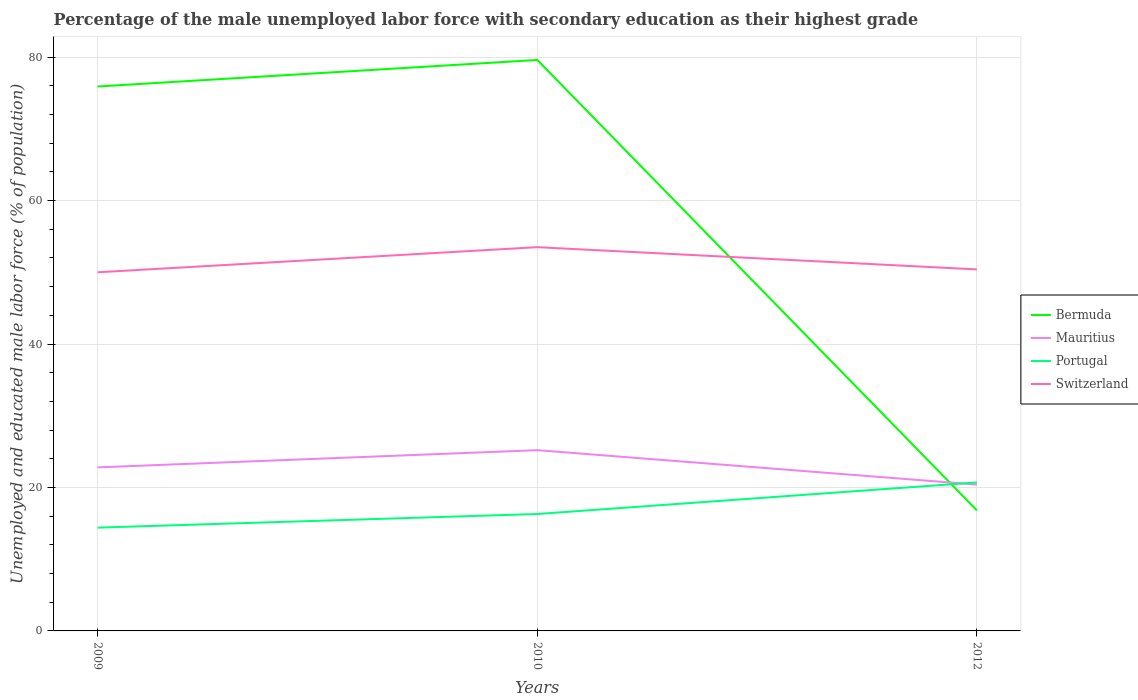How many different coloured lines are there?
Keep it short and to the point. 4. Does the line corresponding to Portugal intersect with the line corresponding to Switzerland?
Offer a very short reply. No. Across all years, what is the maximum percentage of the unemployed male labor force with secondary education in Portugal?
Give a very brief answer. 14.4. What is the total percentage of the unemployed male labor force with secondary education in Bermuda in the graph?
Give a very brief answer. 59.1. What is the difference between the highest and the second highest percentage of the unemployed male labor force with secondary education in Mauritius?
Give a very brief answer. 4.8. Is the percentage of the unemployed male labor force with secondary education in Mauritius strictly greater than the percentage of the unemployed male labor force with secondary education in Switzerland over the years?
Offer a terse response. Yes. How many lines are there?
Provide a succinct answer. 4. What is the difference between two consecutive major ticks on the Y-axis?
Make the answer very short. 20. Are the values on the major ticks of Y-axis written in scientific E-notation?
Provide a short and direct response. No. Does the graph contain any zero values?
Your answer should be compact. No. Does the graph contain grids?
Provide a succinct answer. Yes. How are the legend labels stacked?
Your response must be concise. Vertical. What is the title of the graph?
Offer a very short reply. Percentage of the male unemployed labor force with secondary education as their highest grade. What is the label or title of the X-axis?
Offer a terse response. Years. What is the label or title of the Y-axis?
Provide a short and direct response. Unemployed and educated male labor force (% of population). What is the Unemployed and educated male labor force (% of population) in Bermuda in 2009?
Give a very brief answer. 75.9. What is the Unemployed and educated male labor force (% of population) in Mauritius in 2009?
Keep it short and to the point. 22.8. What is the Unemployed and educated male labor force (% of population) in Portugal in 2009?
Your answer should be very brief. 14.4. What is the Unemployed and educated male labor force (% of population) of Bermuda in 2010?
Your answer should be compact. 79.6. What is the Unemployed and educated male labor force (% of population) of Mauritius in 2010?
Provide a succinct answer. 25.2. What is the Unemployed and educated male labor force (% of population) of Portugal in 2010?
Offer a very short reply. 16.3. What is the Unemployed and educated male labor force (% of population) in Switzerland in 2010?
Offer a terse response. 53.5. What is the Unemployed and educated male labor force (% of population) in Bermuda in 2012?
Make the answer very short. 16.8. What is the Unemployed and educated male labor force (% of population) of Mauritius in 2012?
Offer a very short reply. 20.4. What is the Unemployed and educated male labor force (% of population) in Portugal in 2012?
Make the answer very short. 20.7. What is the Unemployed and educated male labor force (% of population) of Switzerland in 2012?
Give a very brief answer. 50.4. Across all years, what is the maximum Unemployed and educated male labor force (% of population) in Bermuda?
Your answer should be compact. 79.6. Across all years, what is the maximum Unemployed and educated male labor force (% of population) of Mauritius?
Offer a terse response. 25.2. Across all years, what is the maximum Unemployed and educated male labor force (% of population) of Portugal?
Ensure brevity in your answer.  20.7. Across all years, what is the maximum Unemployed and educated male labor force (% of population) of Switzerland?
Provide a succinct answer. 53.5. Across all years, what is the minimum Unemployed and educated male labor force (% of population) of Bermuda?
Your response must be concise. 16.8. Across all years, what is the minimum Unemployed and educated male labor force (% of population) of Mauritius?
Keep it short and to the point. 20.4. Across all years, what is the minimum Unemployed and educated male labor force (% of population) in Portugal?
Keep it short and to the point. 14.4. What is the total Unemployed and educated male labor force (% of population) of Bermuda in the graph?
Your answer should be very brief. 172.3. What is the total Unemployed and educated male labor force (% of population) of Mauritius in the graph?
Make the answer very short. 68.4. What is the total Unemployed and educated male labor force (% of population) in Portugal in the graph?
Provide a short and direct response. 51.4. What is the total Unemployed and educated male labor force (% of population) in Switzerland in the graph?
Your answer should be compact. 153.9. What is the difference between the Unemployed and educated male labor force (% of population) of Mauritius in 2009 and that in 2010?
Provide a succinct answer. -2.4. What is the difference between the Unemployed and educated male labor force (% of population) in Portugal in 2009 and that in 2010?
Your answer should be very brief. -1.9. What is the difference between the Unemployed and educated male labor force (% of population) of Switzerland in 2009 and that in 2010?
Provide a succinct answer. -3.5. What is the difference between the Unemployed and educated male labor force (% of population) of Bermuda in 2009 and that in 2012?
Provide a short and direct response. 59.1. What is the difference between the Unemployed and educated male labor force (% of population) in Portugal in 2009 and that in 2012?
Your response must be concise. -6.3. What is the difference between the Unemployed and educated male labor force (% of population) in Bermuda in 2010 and that in 2012?
Your answer should be compact. 62.8. What is the difference between the Unemployed and educated male labor force (% of population) of Mauritius in 2010 and that in 2012?
Offer a very short reply. 4.8. What is the difference between the Unemployed and educated male labor force (% of population) in Portugal in 2010 and that in 2012?
Your answer should be very brief. -4.4. What is the difference between the Unemployed and educated male labor force (% of population) in Switzerland in 2010 and that in 2012?
Provide a short and direct response. 3.1. What is the difference between the Unemployed and educated male labor force (% of population) of Bermuda in 2009 and the Unemployed and educated male labor force (% of population) of Mauritius in 2010?
Your answer should be very brief. 50.7. What is the difference between the Unemployed and educated male labor force (% of population) in Bermuda in 2009 and the Unemployed and educated male labor force (% of population) in Portugal in 2010?
Offer a very short reply. 59.6. What is the difference between the Unemployed and educated male labor force (% of population) in Bermuda in 2009 and the Unemployed and educated male labor force (% of population) in Switzerland in 2010?
Provide a short and direct response. 22.4. What is the difference between the Unemployed and educated male labor force (% of population) in Mauritius in 2009 and the Unemployed and educated male labor force (% of population) in Switzerland in 2010?
Your response must be concise. -30.7. What is the difference between the Unemployed and educated male labor force (% of population) in Portugal in 2009 and the Unemployed and educated male labor force (% of population) in Switzerland in 2010?
Your answer should be compact. -39.1. What is the difference between the Unemployed and educated male labor force (% of population) of Bermuda in 2009 and the Unemployed and educated male labor force (% of population) of Mauritius in 2012?
Make the answer very short. 55.5. What is the difference between the Unemployed and educated male labor force (% of population) of Bermuda in 2009 and the Unemployed and educated male labor force (% of population) of Portugal in 2012?
Provide a succinct answer. 55.2. What is the difference between the Unemployed and educated male labor force (% of population) of Bermuda in 2009 and the Unemployed and educated male labor force (% of population) of Switzerland in 2012?
Offer a terse response. 25.5. What is the difference between the Unemployed and educated male labor force (% of population) of Mauritius in 2009 and the Unemployed and educated male labor force (% of population) of Portugal in 2012?
Keep it short and to the point. 2.1. What is the difference between the Unemployed and educated male labor force (% of population) in Mauritius in 2009 and the Unemployed and educated male labor force (% of population) in Switzerland in 2012?
Keep it short and to the point. -27.6. What is the difference between the Unemployed and educated male labor force (% of population) in Portugal in 2009 and the Unemployed and educated male labor force (% of population) in Switzerland in 2012?
Provide a succinct answer. -36. What is the difference between the Unemployed and educated male labor force (% of population) in Bermuda in 2010 and the Unemployed and educated male labor force (% of population) in Mauritius in 2012?
Provide a succinct answer. 59.2. What is the difference between the Unemployed and educated male labor force (% of population) in Bermuda in 2010 and the Unemployed and educated male labor force (% of population) in Portugal in 2012?
Your answer should be very brief. 58.9. What is the difference between the Unemployed and educated male labor force (% of population) in Bermuda in 2010 and the Unemployed and educated male labor force (% of population) in Switzerland in 2012?
Give a very brief answer. 29.2. What is the difference between the Unemployed and educated male labor force (% of population) of Mauritius in 2010 and the Unemployed and educated male labor force (% of population) of Portugal in 2012?
Your answer should be very brief. 4.5. What is the difference between the Unemployed and educated male labor force (% of population) in Mauritius in 2010 and the Unemployed and educated male labor force (% of population) in Switzerland in 2012?
Make the answer very short. -25.2. What is the difference between the Unemployed and educated male labor force (% of population) of Portugal in 2010 and the Unemployed and educated male labor force (% of population) of Switzerland in 2012?
Ensure brevity in your answer.  -34.1. What is the average Unemployed and educated male labor force (% of population) of Bermuda per year?
Ensure brevity in your answer.  57.43. What is the average Unemployed and educated male labor force (% of population) of Mauritius per year?
Make the answer very short. 22.8. What is the average Unemployed and educated male labor force (% of population) in Portugal per year?
Your answer should be compact. 17.13. What is the average Unemployed and educated male labor force (% of population) in Switzerland per year?
Offer a very short reply. 51.3. In the year 2009, what is the difference between the Unemployed and educated male labor force (% of population) in Bermuda and Unemployed and educated male labor force (% of population) in Mauritius?
Keep it short and to the point. 53.1. In the year 2009, what is the difference between the Unemployed and educated male labor force (% of population) of Bermuda and Unemployed and educated male labor force (% of population) of Portugal?
Provide a short and direct response. 61.5. In the year 2009, what is the difference between the Unemployed and educated male labor force (% of population) of Bermuda and Unemployed and educated male labor force (% of population) of Switzerland?
Give a very brief answer. 25.9. In the year 2009, what is the difference between the Unemployed and educated male labor force (% of population) of Mauritius and Unemployed and educated male labor force (% of population) of Portugal?
Offer a terse response. 8.4. In the year 2009, what is the difference between the Unemployed and educated male labor force (% of population) in Mauritius and Unemployed and educated male labor force (% of population) in Switzerland?
Your response must be concise. -27.2. In the year 2009, what is the difference between the Unemployed and educated male labor force (% of population) in Portugal and Unemployed and educated male labor force (% of population) in Switzerland?
Offer a terse response. -35.6. In the year 2010, what is the difference between the Unemployed and educated male labor force (% of population) in Bermuda and Unemployed and educated male labor force (% of population) in Mauritius?
Give a very brief answer. 54.4. In the year 2010, what is the difference between the Unemployed and educated male labor force (% of population) of Bermuda and Unemployed and educated male labor force (% of population) of Portugal?
Offer a very short reply. 63.3. In the year 2010, what is the difference between the Unemployed and educated male labor force (% of population) in Bermuda and Unemployed and educated male labor force (% of population) in Switzerland?
Provide a short and direct response. 26.1. In the year 2010, what is the difference between the Unemployed and educated male labor force (% of population) in Mauritius and Unemployed and educated male labor force (% of population) in Switzerland?
Your response must be concise. -28.3. In the year 2010, what is the difference between the Unemployed and educated male labor force (% of population) of Portugal and Unemployed and educated male labor force (% of population) of Switzerland?
Provide a succinct answer. -37.2. In the year 2012, what is the difference between the Unemployed and educated male labor force (% of population) of Bermuda and Unemployed and educated male labor force (% of population) of Switzerland?
Your answer should be very brief. -33.6. In the year 2012, what is the difference between the Unemployed and educated male labor force (% of population) in Portugal and Unemployed and educated male labor force (% of population) in Switzerland?
Your answer should be compact. -29.7. What is the ratio of the Unemployed and educated male labor force (% of population) in Bermuda in 2009 to that in 2010?
Your answer should be very brief. 0.95. What is the ratio of the Unemployed and educated male labor force (% of population) in Mauritius in 2009 to that in 2010?
Your answer should be compact. 0.9. What is the ratio of the Unemployed and educated male labor force (% of population) of Portugal in 2009 to that in 2010?
Your answer should be very brief. 0.88. What is the ratio of the Unemployed and educated male labor force (% of population) in Switzerland in 2009 to that in 2010?
Provide a short and direct response. 0.93. What is the ratio of the Unemployed and educated male labor force (% of population) in Bermuda in 2009 to that in 2012?
Provide a short and direct response. 4.52. What is the ratio of the Unemployed and educated male labor force (% of population) of Mauritius in 2009 to that in 2012?
Your response must be concise. 1.12. What is the ratio of the Unemployed and educated male labor force (% of population) in Portugal in 2009 to that in 2012?
Ensure brevity in your answer.  0.7. What is the ratio of the Unemployed and educated male labor force (% of population) of Bermuda in 2010 to that in 2012?
Your response must be concise. 4.74. What is the ratio of the Unemployed and educated male labor force (% of population) in Mauritius in 2010 to that in 2012?
Offer a terse response. 1.24. What is the ratio of the Unemployed and educated male labor force (% of population) in Portugal in 2010 to that in 2012?
Keep it short and to the point. 0.79. What is the ratio of the Unemployed and educated male labor force (% of population) in Switzerland in 2010 to that in 2012?
Your answer should be compact. 1.06. What is the difference between the highest and the second highest Unemployed and educated male labor force (% of population) of Bermuda?
Your answer should be compact. 3.7. What is the difference between the highest and the second highest Unemployed and educated male labor force (% of population) in Mauritius?
Offer a terse response. 2.4. What is the difference between the highest and the second highest Unemployed and educated male labor force (% of population) in Portugal?
Ensure brevity in your answer.  4.4. What is the difference between the highest and the second highest Unemployed and educated male labor force (% of population) of Switzerland?
Offer a very short reply. 3.1. What is the difference between the highest and the lowest Unemployed and educated male labor force (% of population) of Bermuda?
Ensure brevity in your answer.  62.8. What is the difference between the highest and the lowest Unemployed and educated male labor force (% of population) of Mauritius?
Ensure brevity in your answer.  4.8. What is the difference between the highest and the lowest Unemployed and educated male labor force (% of population) of Portugal?
Give a very brief answer. 6.3. 